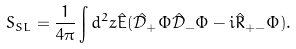<formula> <loc_0><loc_0><loc_500><loc_500>S _ { S L } = \frac { 1 } { 4 \pi } \int d ^ { 2 } z \hat { E } ( \hat { \mathcal { D } } _ { + } \Phi \hat { \mathcal { D } } _ { - } \Phi - i \hat { R } _ { + - } \Phi ) .</formula> 